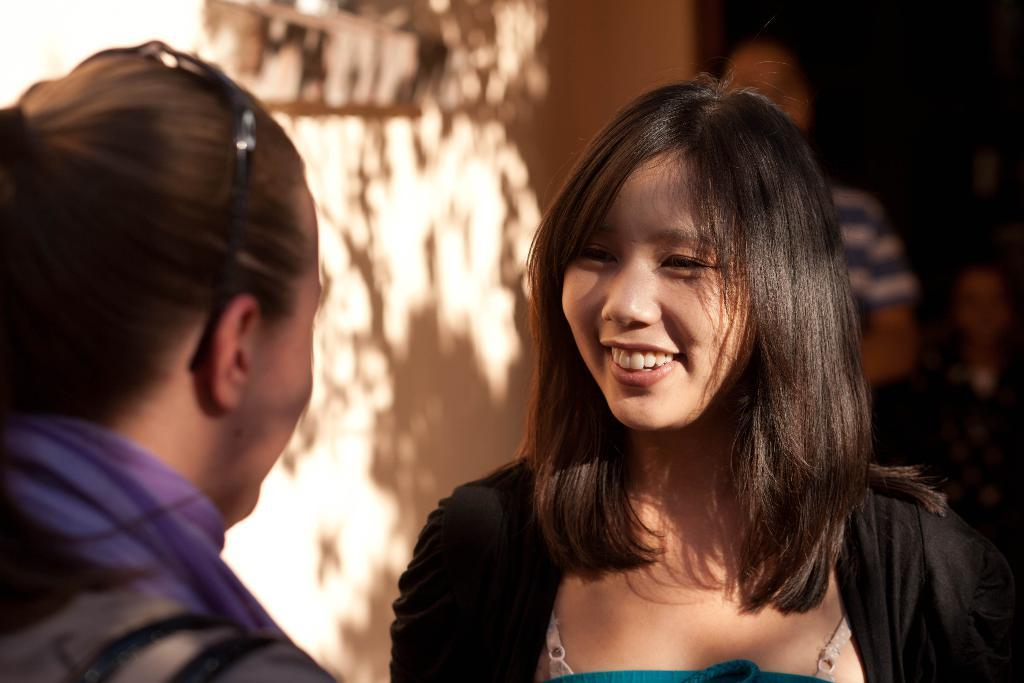How many people are in the image? There are people in the image, but the exact number is not specified. What is the woman in the image doing? The woman is smiling and watching another person. Can you describe the background of the image? The background of the image is blurred, but a wall is visible. What type of oatmeal is being served on the square plate in the image? There is no oatmeal or plate present in the image. What is the woman's desire in the image? The facts provided do not give any information about the woman's desires, so we cannot determine her desire from the image. 